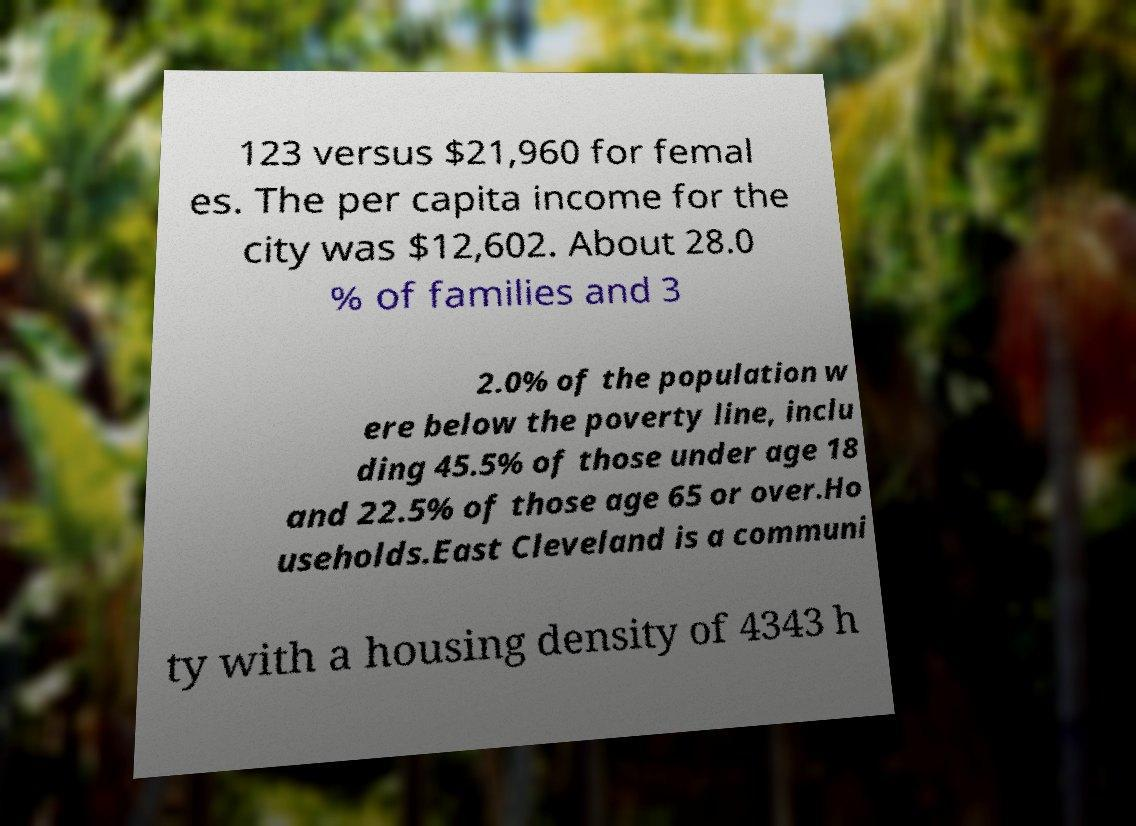Can you read and provide the text displayed in the image?This photo seems to have some interesting text. Can you extract and type it out for me? 123 versus $21,960 for femal es. The per capita income for the city was $12,602. About 28.0 % of families and 3 2.0% of the population w ere below the poverty line, inclu ding 45.5% of those under age 18 and 22.5% of those age 65 or over.Ho useholds.East Cleveland is a communi ty with a housing density of 4343 h 